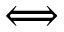Convert formula to latex. <formula><loc_0><loc_0><loc_500><loc_500>\Longleftrightarrow</formula> 